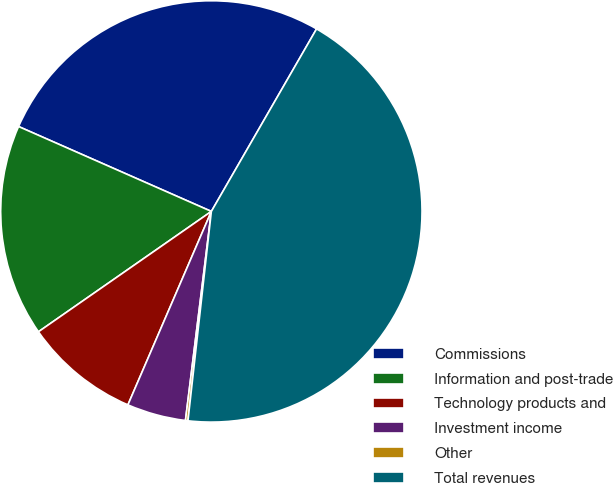Convert chart to OTSL. <chart><loc_0><loc_0><loc_500><loc_500><pie_chart><fcel>Commissions<fcel>Information and post-trade<fcel>Technology products and<fcel>Investment income<fcel>Other<fcel>Total revenues<nl><fcel>26.72%<fcel>16.28%<fcel>8.84%<fcel>4.52%<fcel>0.19%<fcel>43.45%<nl></chart> 